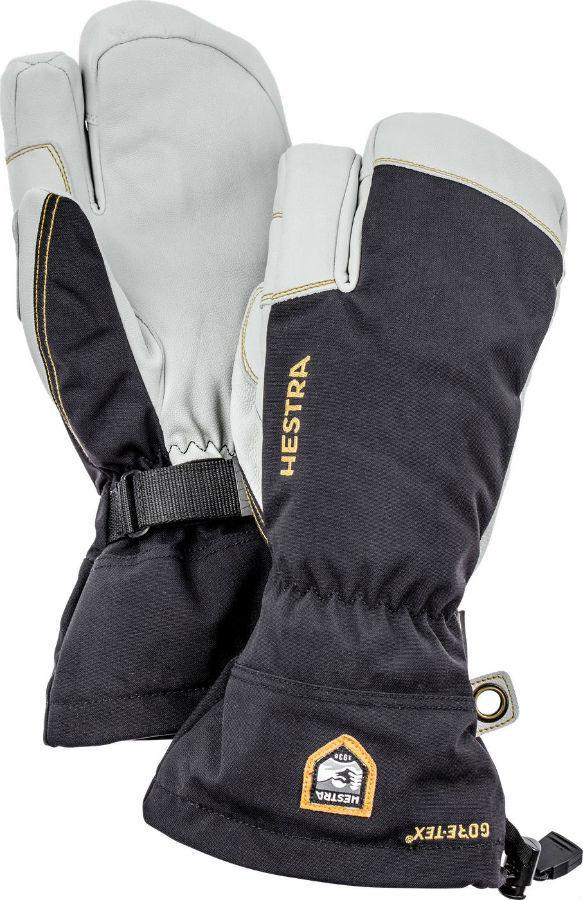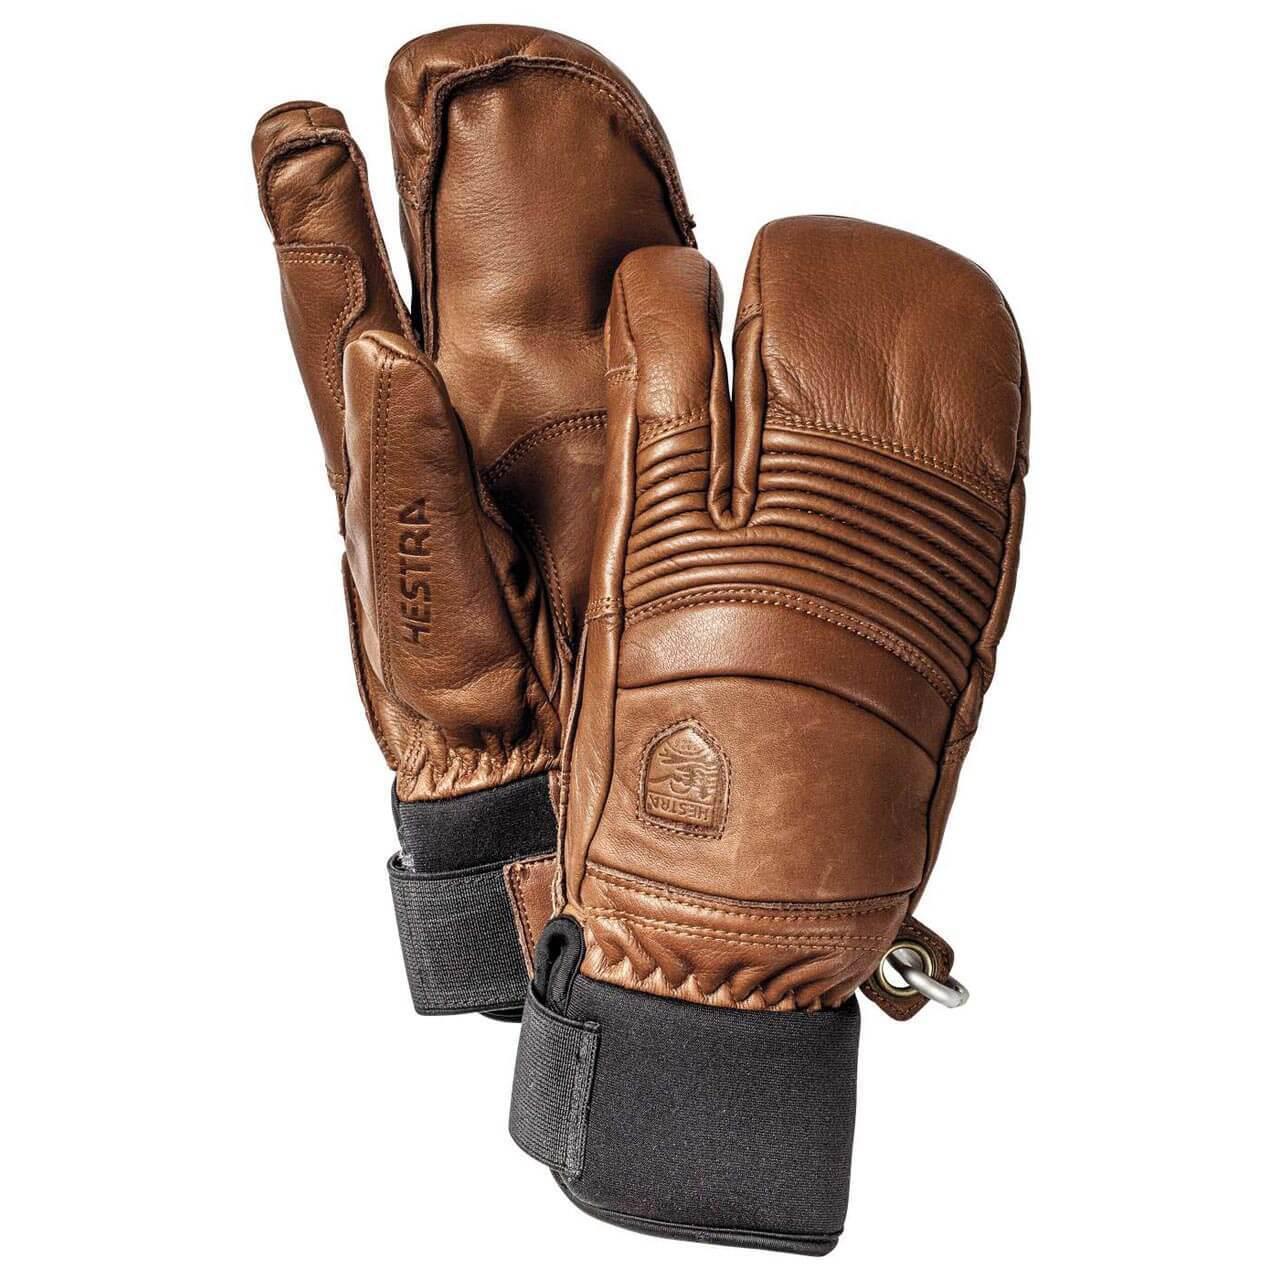The first image is the image on the left, the second image is the image on the right. For the images shown, is this caption "There is a pair of brown leather mittens in one of the images." true? Answer yes or no. Yes. The first image is the image on the left, the second image is the image on the right. Evaluate the accuracy of this statement regarding the images: "Every mitten has a white tip and palm.". Is it true? Answer yes or no. No. 